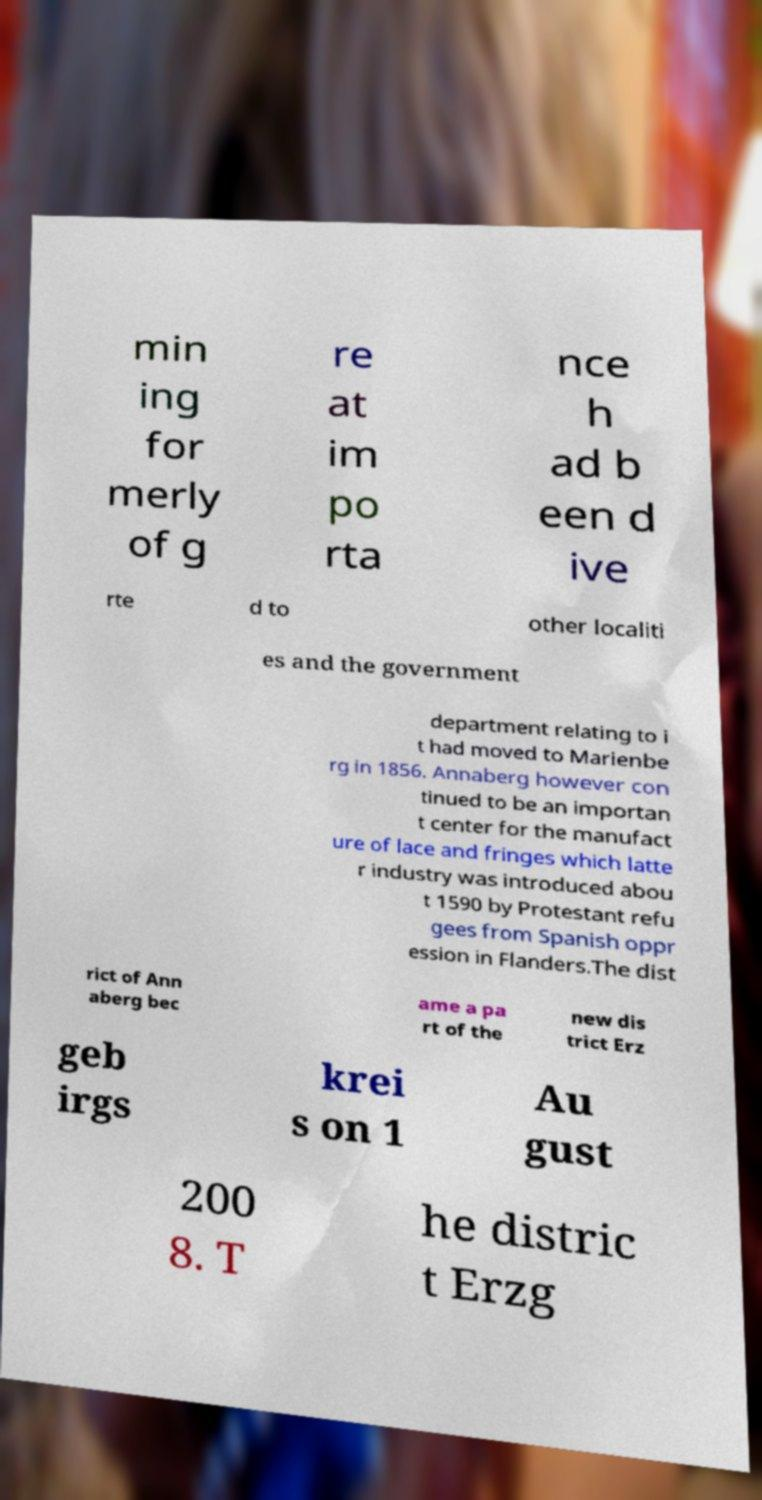Can you read and provide the text displayed in the image?This photo seems to have some interesting text. Can you extract and type it out for me? min ing for merly of g re at im po rta nce h ad b een d ive rte d to other localiti es and the government department relating to i t had moved to Marienbe rg in 1856. Annaberg however con tinued to be an importan t center for the manufact ure of lace and fringes which latte r industry was introduced abou t 1590 by Protestant refu gees from Spanish oppr ession in Flanders.The dist rict of Ann aberg bec ame a pa rt of the new dis trict Erz geb irgs krei s on 1 Au gust 200 8. T he distric t Erzg 